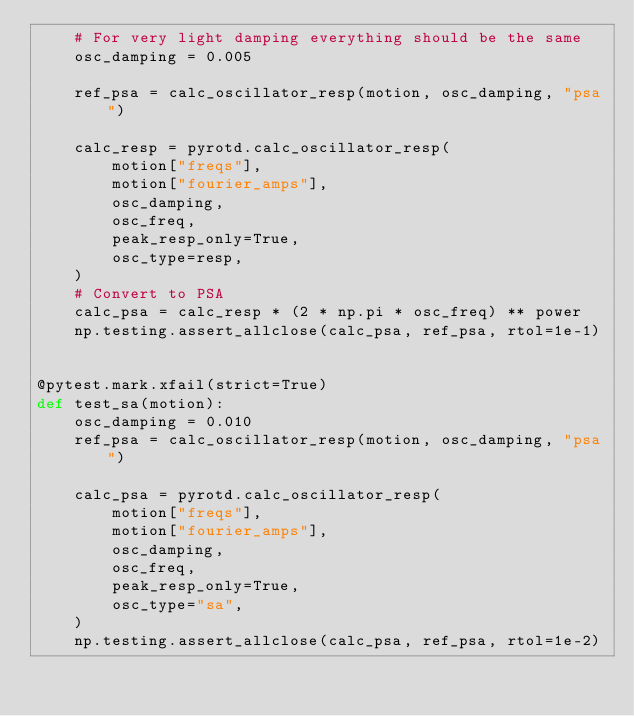Convert code to text. <code><loc_0><loc_0><loc_500><loc_500><_Python_>    # For very light damping everything should be the same
    osc_damping = 0.005

    ref_psa = calc_oscillator_resp(motion, osc_damping, "psa")

    calc_resp = pyrotd.calc_oscillator_resp(
        motion["freqs"],
        motion["fourier_amps"],
        osc_damping,
        osc_freq,
        peak_resp_only=True,
        osc_type=resp,
    )
    # Convert to PSA
    calc_psa = calc_resp * (2 * np.pi * osc_freq) ** power
    np.testing.assert_allclose(calc_psa, ref_psa, rtol=1e-1)


@pytest.mark.xfail(strict=True)
def test_sa(motion):
    osc_damping = 0.010
    ref_psa = calc_oscillator_resp(motion, osc_damping, "psa")

    calc_psa = pyrotd.calc_oscillator_resp(
        motion["freqs"],
        motion["fourier_amps"],
        osc_damping,
        osc_freq,
        peak_resp_only=True,
        osc_type="sa",
    )
    np.testing.assert_allclose(calc_psa, ref_psa, rtol=1e-2)
</code> 